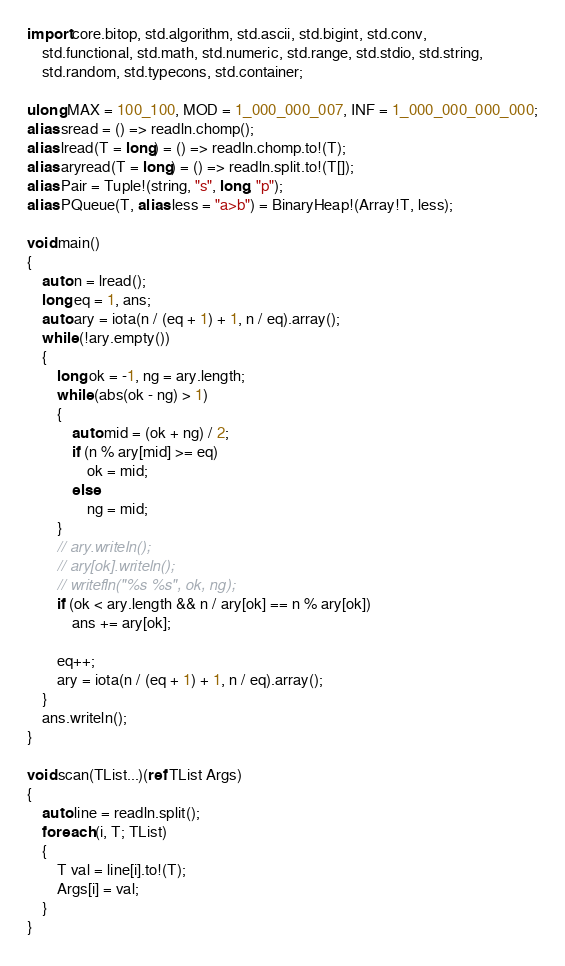<code> <loc_0><loc_0><loc_500><loc_500><_D_>import core.bitop, std.algorithm, std.ascii, std.bigint, std.conv,
    std.functional, std.math, std.numeric, std.range, std.stdio, std.string,
    std.random, std.typecons, std.container;

ulong MAX = 100_100, MOD = 1_000_000_007, INF = 1_000_000_000_000;
alias sread = () => readln.chomp();
alias lread(T = long) = () => readln.chomp.to!(T);
alias aryread(T = long) = () => readln.split.to!(T[]);
alias Pair = Tuple!(string, "s", long, "p");
alias PQueue(T, alias less = "a>b") = BinaryHeap!(Array!T, less);

void main()
{
    auto n = lread();
    long eq = 1, ans;
    auto ary = iota(n / (eq + 1) + 1, n / eq).array();
    while (!ary.empty())
    {
        long ok = -1, ng = ary.length;
        while (abs(ok - ng) > 1)
        {
            auto mid = (ok + ng) / 2;
            if (n % ary[mid] >= eq)
                ok = mid;
            else
                ng = mid;
        }
        // ary.writeln();
        // ary[ok].writeln();
        // writefln("%s %s", ok, ng);
        if (ok < ary.length && n / ary[ok] == n % ary[ok])
            ans += ary[ok];

        eq++;
        ary = iota(n / (eq + 1) + 1, n / eq).array();
    }
    ans.writeln();
}

void scan(TList...)(ref TList Args)
{
    auto line = readln.split();
    foreach (i, T; TList)
    {
        T val = line[i].to!(T);
        Args[i] = val;
    }
}
</code> 